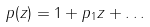Convert formula to latex. <formula><loc_0><loc_0><loc_500><loc_500>p ( z ) = 1 + p _ { 1 } z + \dots \,</formula> 